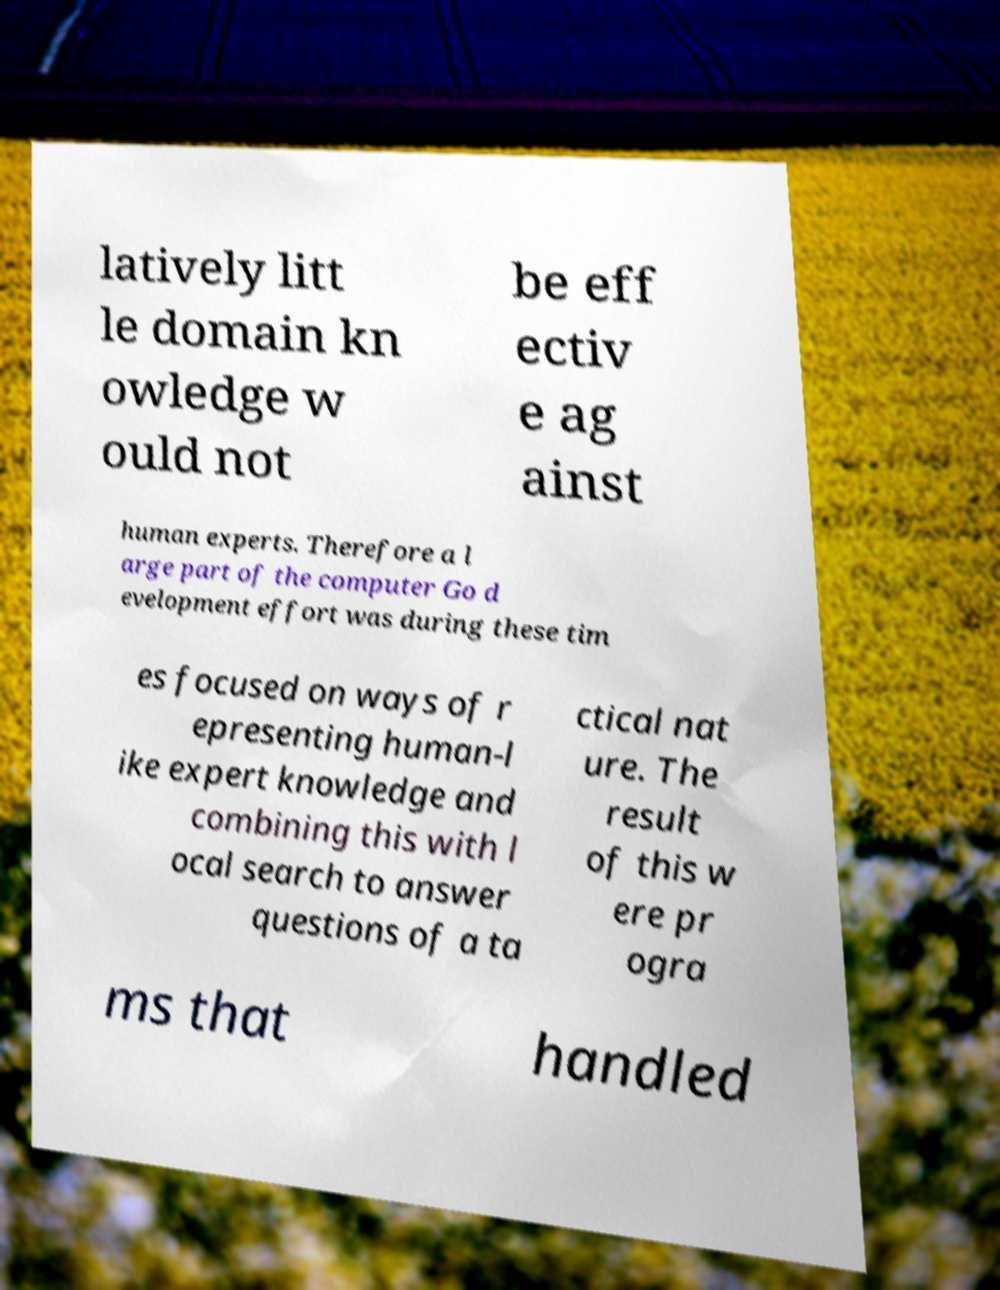Can you read and provide the text displayed in the image?This photo seems to have some interesting text. Can you extract and type it out for me? latively litt le domain kn owledge w ould not be eff ectiv e ag ainst human experts. Therefore a l arge part of the computer Go d evelopment effort was during these tim es focused on ways of r epresenting human-l ike expert knowledge and combining this with l ocal search to answer questions of a ta ctical nat ure. The result of this w ere pr ogra ms that handled 